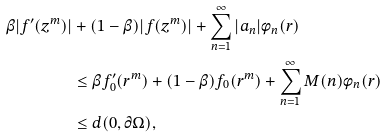<formula> <loc_0><loc_0><loc_500><loc_500>\beta | f ^ { \prime } ( z ^ { m } ) | & + ( 1 - \beta ) | f ( z ^ { m } ) | + \sum _ { n = 1 } ^ { \infty } | a _ { n } | \phi _ { n } ( r ) \\ & \leq \beta f ^ { \prime } _ { 0 } ( r ^ { m } ) + ( 1 - \beta ) f _ { 0 } ( r ^ { m } ) + \sum _ { n = 1 } ^ { \infty } M ( n ) \phi _ { n } ( r ) \\ & \leq d ( 0 , \partial { \Omega } ) ,</formula> 